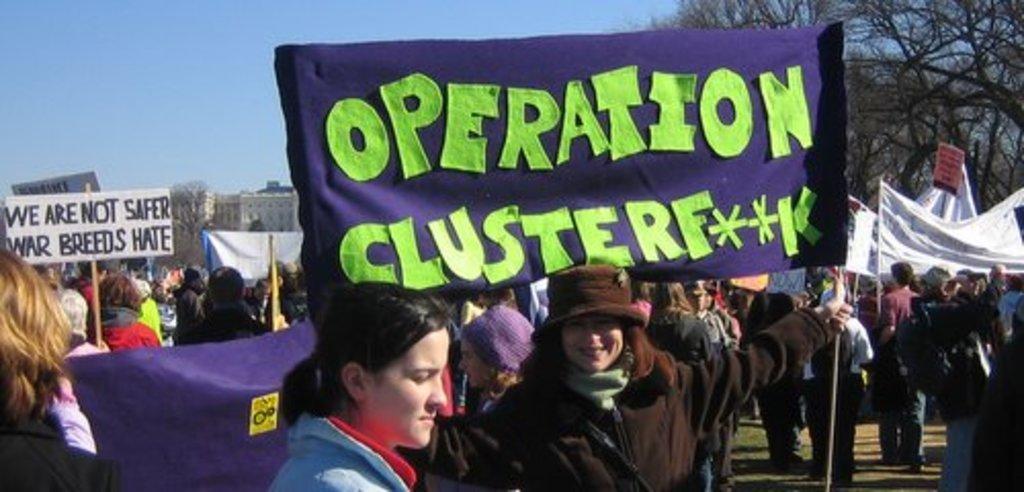Describe this image in one or two sentences. People are standing holding banners and placards. Behind them there are trees and buildings. 